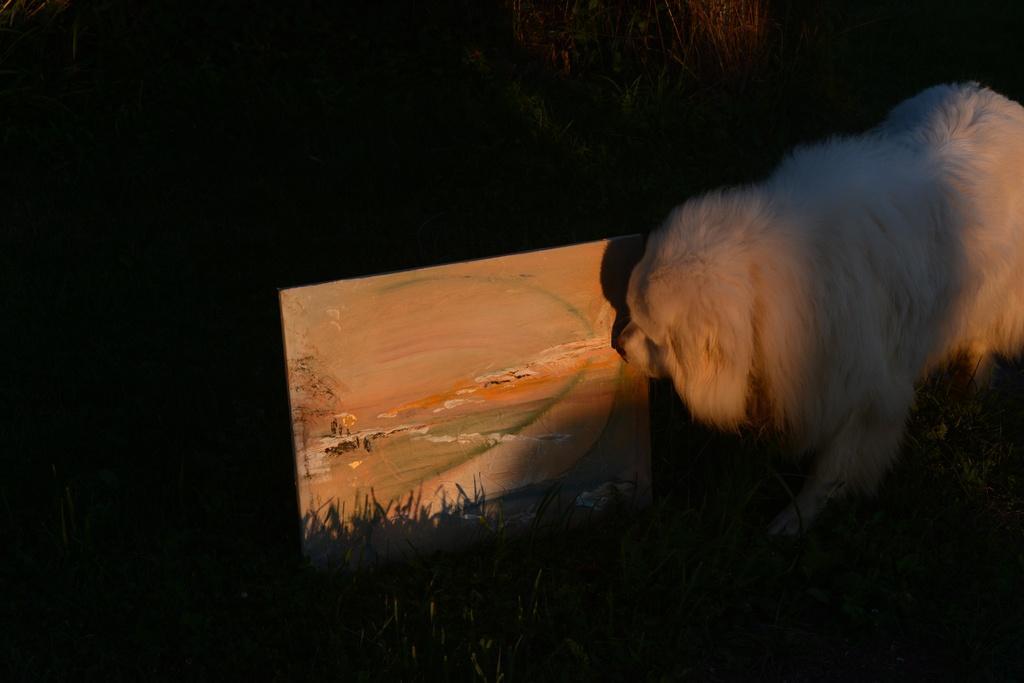In one or two sentences, can you explain what this image depicts? In this picture there is a dog on the right side of the image and there is a portrait in the center of the image. 